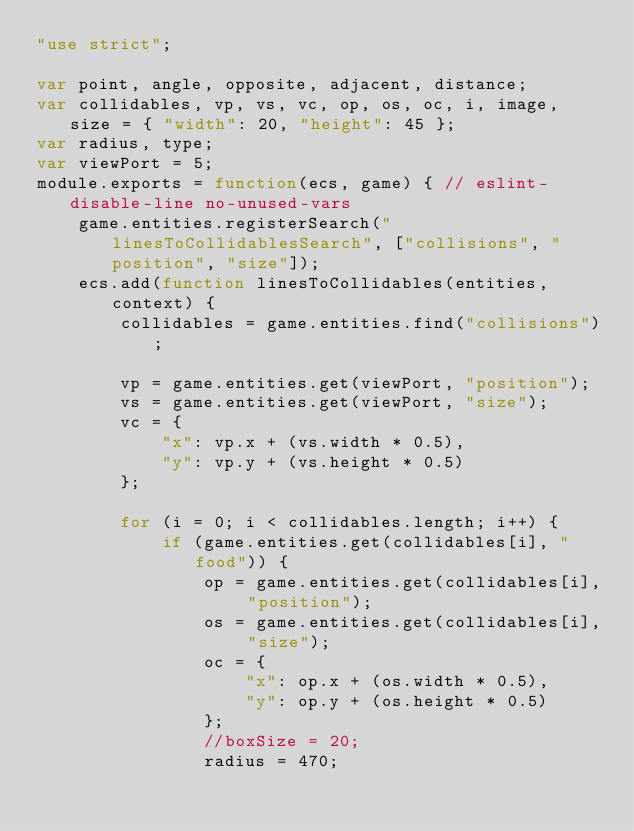<code> <loc_0><loc_0><loc_500><loc_500><_JavaScript_>"use strict";

var point, angle, opposite, adjacent, distance;
var collidables, vp, vs, vc, op, os, oc, i, image, size = { "width": 20, "height": 45 };
var radius, type;
var viewPort = 5;
module.exports = function(ecs, game) { // eslint-disable-line no-unused-vars
    game.entities.registerSearch("linesToCollidablesSearch", ["collisions", "position", "size"]);
    ecs.add(function linesToCollidables(entities, context) {
        collidables = game.entities.find("collisions");

        vp = game.entities.get(viewPort, "position");
        vs = game.entities.get(viewPort, "size");
        vc = {
            "x": vp.x + (vs.width * 0.5),
            "y": vp.y + (vs.height * 0.5)
        };

        for (i = 0; i < collidables.length; i++) {
            if (game.entities.get(collidables[i], "food")) {
                op = game.entities.get(collidables[i], "position");
                os = game.entities.get(collidables[i], "size");
                oc = {
                    "x": op.x + (os.width * 0.5),
                    "y": op.y + (os.height * 0.5)
                };
                //boxSize = 20;
                radius = 470;</code> 